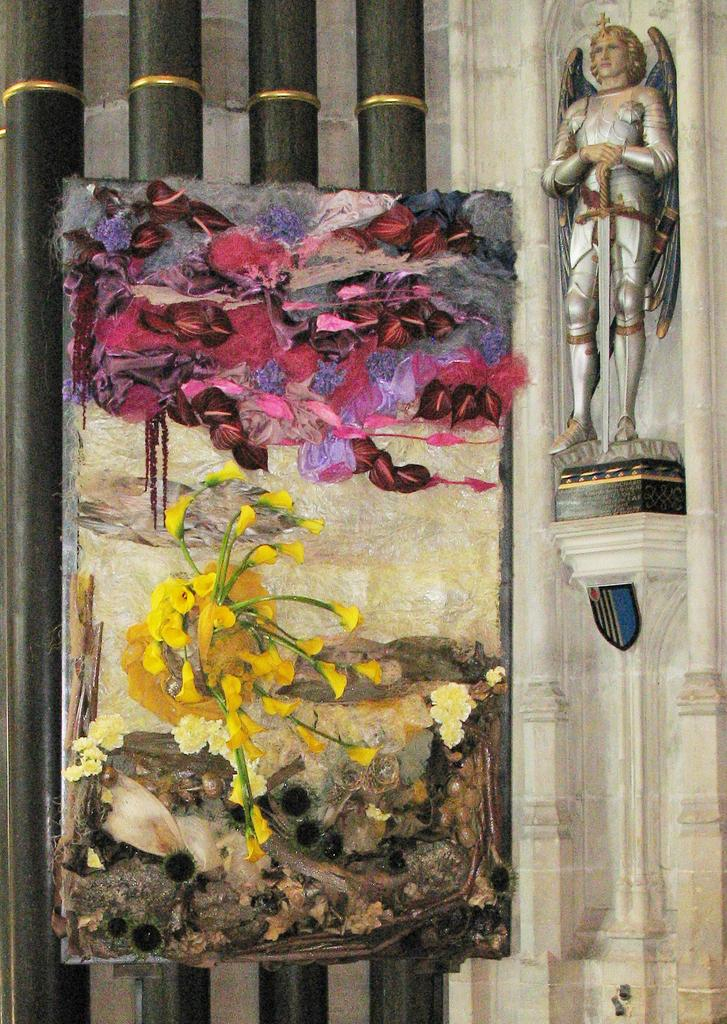What can be seen on the left side of the image? There are four poles on the left side of the image. What is depicted on the poles? There is a painting on the poles. What is located on the right side of the image? There is a statue on the right side of the image. Where is the statue positioned in relation to the wall? The statue is on the wall. What type of market is represented by the painting on the poles? There is no indication of a market or any representation of a market in the image. The painting on the poles is not described in the facts provided. 